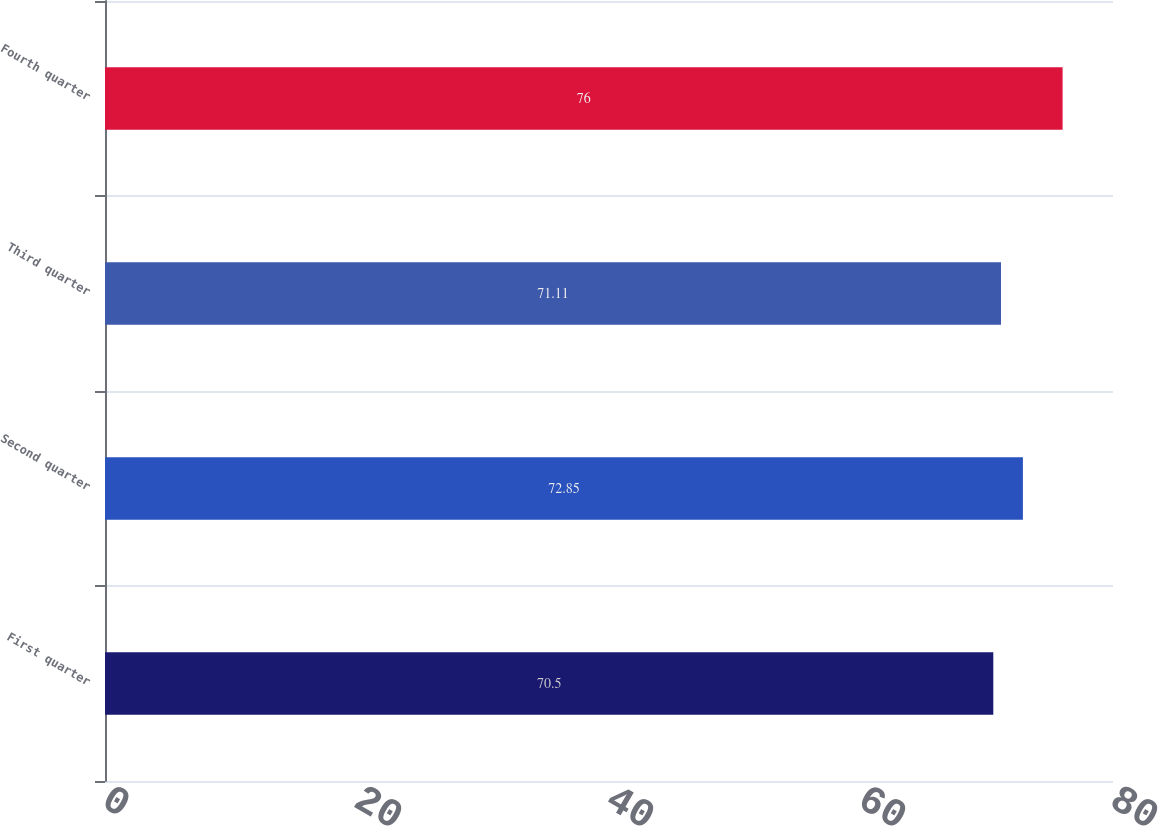Convert chart. <chart><loc_0><loc_0><loc_500><loc_500><bar_chart><fcel>First quarter<fcel>Second quarter<fcel>Third quarter<fcel>Fourth quarter<nl><fcel>70.5<fcel>72.85<fcel>71.11<fcel>76<nl></chart> 